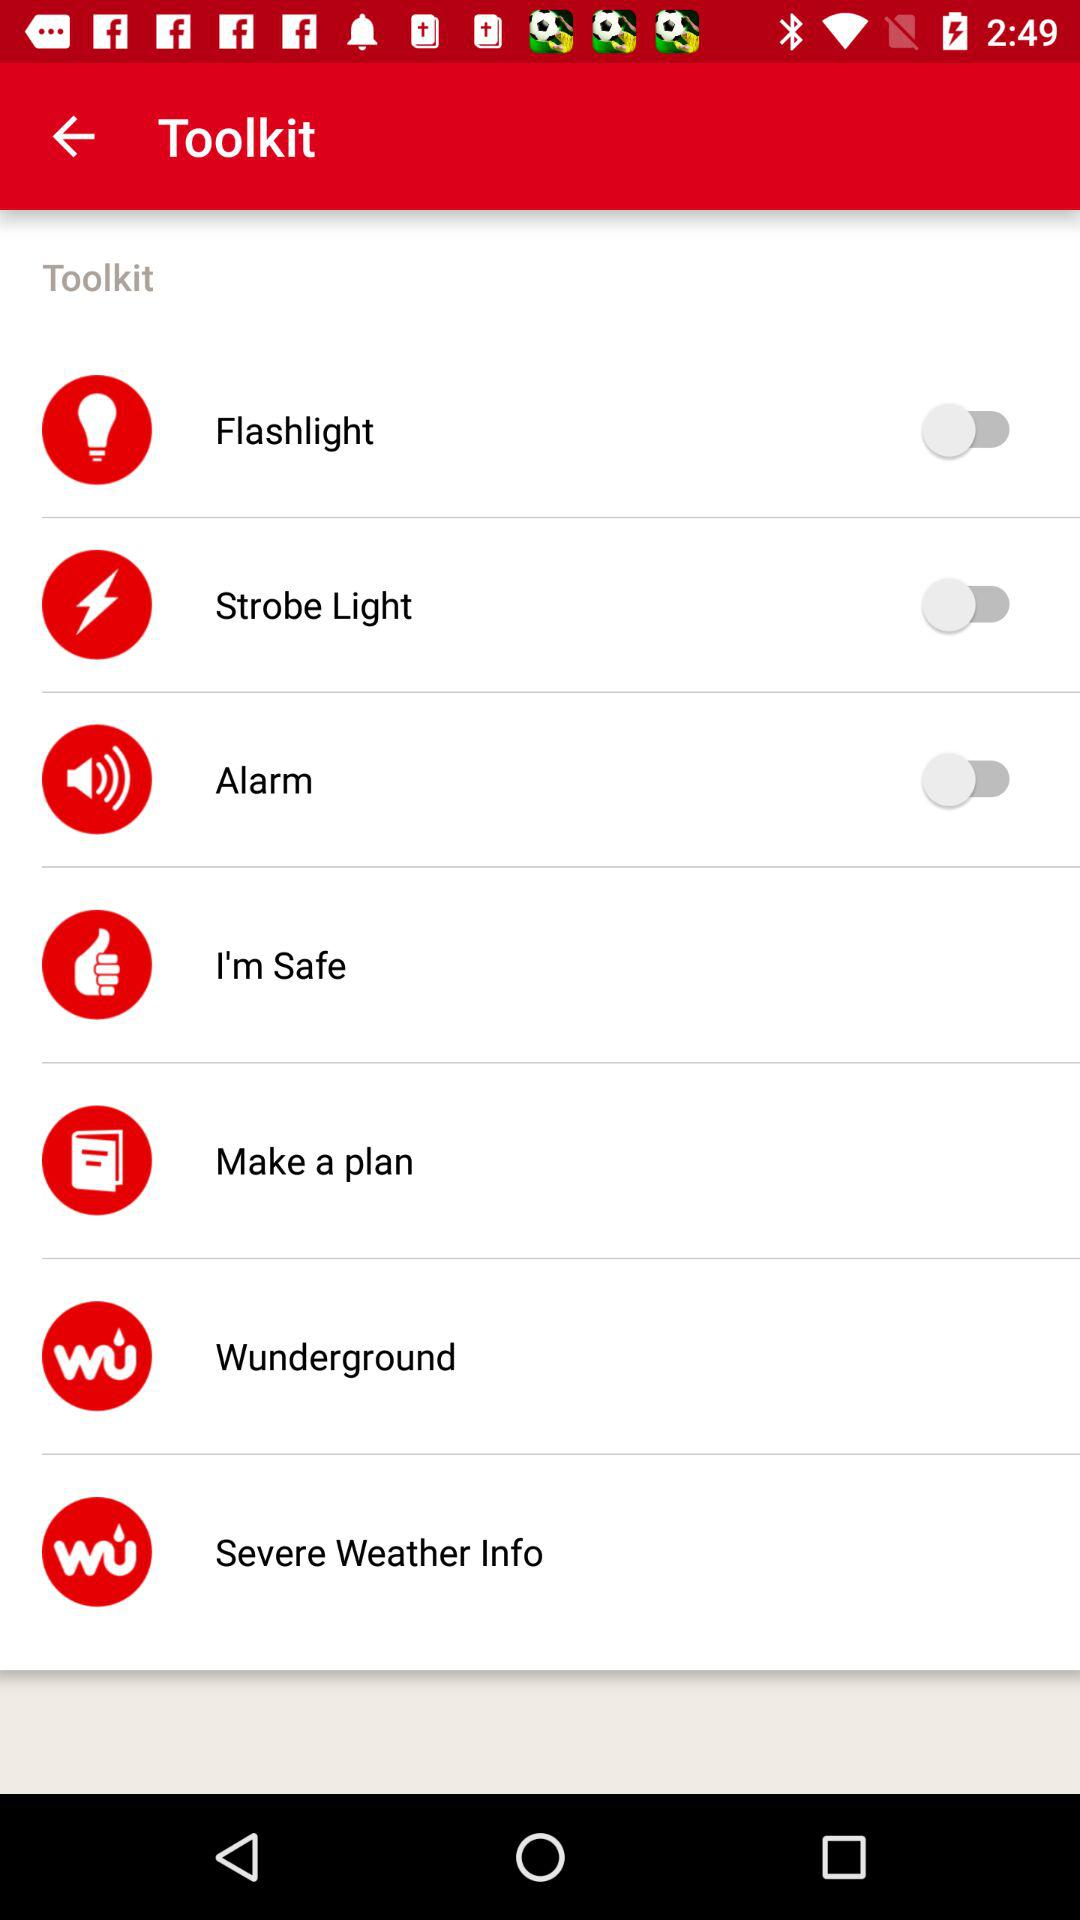What is the status of "Alarm"? The status is "off". 